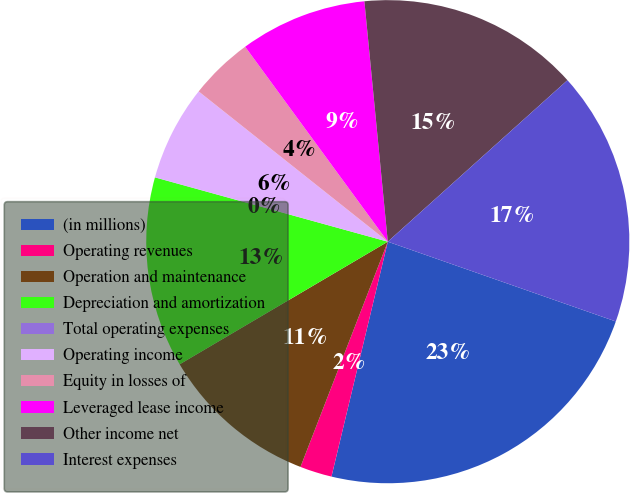Convert chart to OTSL. <chart><loc_0><loc_0><loc_500><loc_500><pie_chart><fcel>(in millions)<fcel>Operating revenues<fcel>Operation and maintenance<fcel>Depreciation and amortization<fcel>Total operating expenses<fcel>Operating income<fcel>Equity in losses of<fcel>Leveraged lease income<fcel>Other income net<fcel>Interest expenses<nl><fcel>23.39%<fcel>2.14%<fcel>10.64%<fcel>12.76%<fcel>0.01%<fcel>6.39%<fcel>4.26%<fcel>8.51%<fcel>14.89%<fcel>17.01%<nl></chart> 